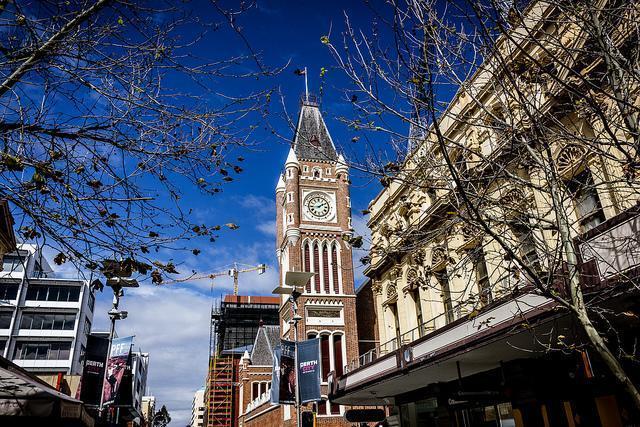How many people are in the water?
Give a very brief answer. 0. 